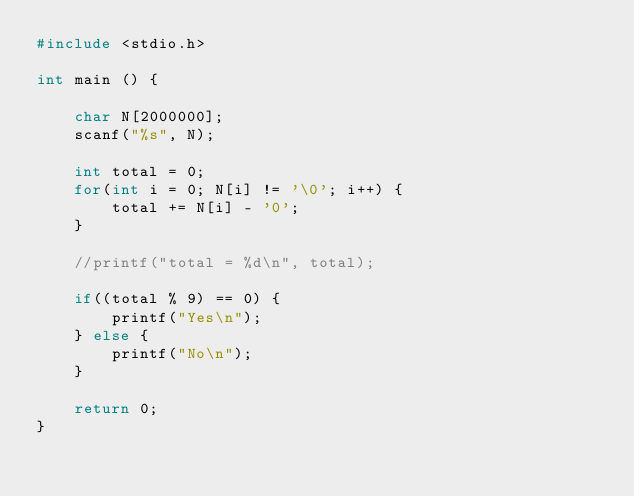Convert code to text. <code><loc_0><loc_0><loc_500><loc_500><_C_>#include <stdio.h>

int main () {

	char N[2000000];
	scanf("%s", N);
	
	int total = 0; 
	for(int i = 0; N[i] != '\0'; i++) {
		total += N[i] - '0';
	}
	
	//printf("total = %d\n", total);

	if((total % 9) == 0) {
		printf("Yes\n");
	} else {
		printf("No\n");
	}

	return 0;
}</code> 